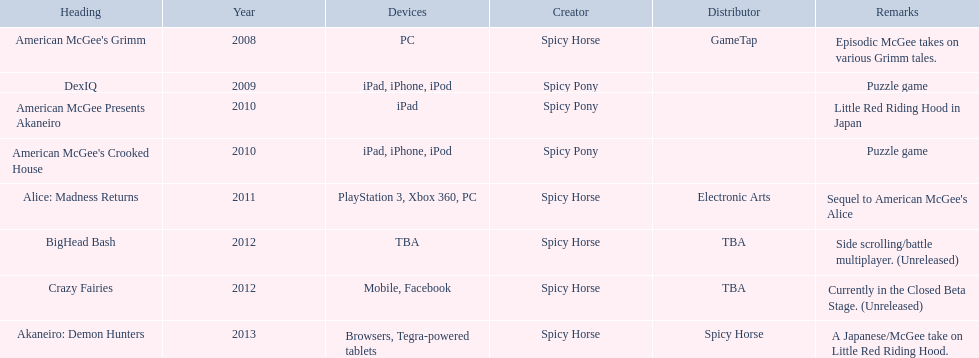What are all of the titles? American McGee's Grimm, DexIQ, American McGee Presents Akaneiro, American McGee's Crooked House, Alice: Madness Returns, BigHead Bash, Crazy Fairies, Akaneiro: Demon Hunters. Who published each title? GameTap, , , , Electronic Arts, TBA, TBA, Spicy Horse. Which game was published by electronics arts? Alice: Madness Returns. 